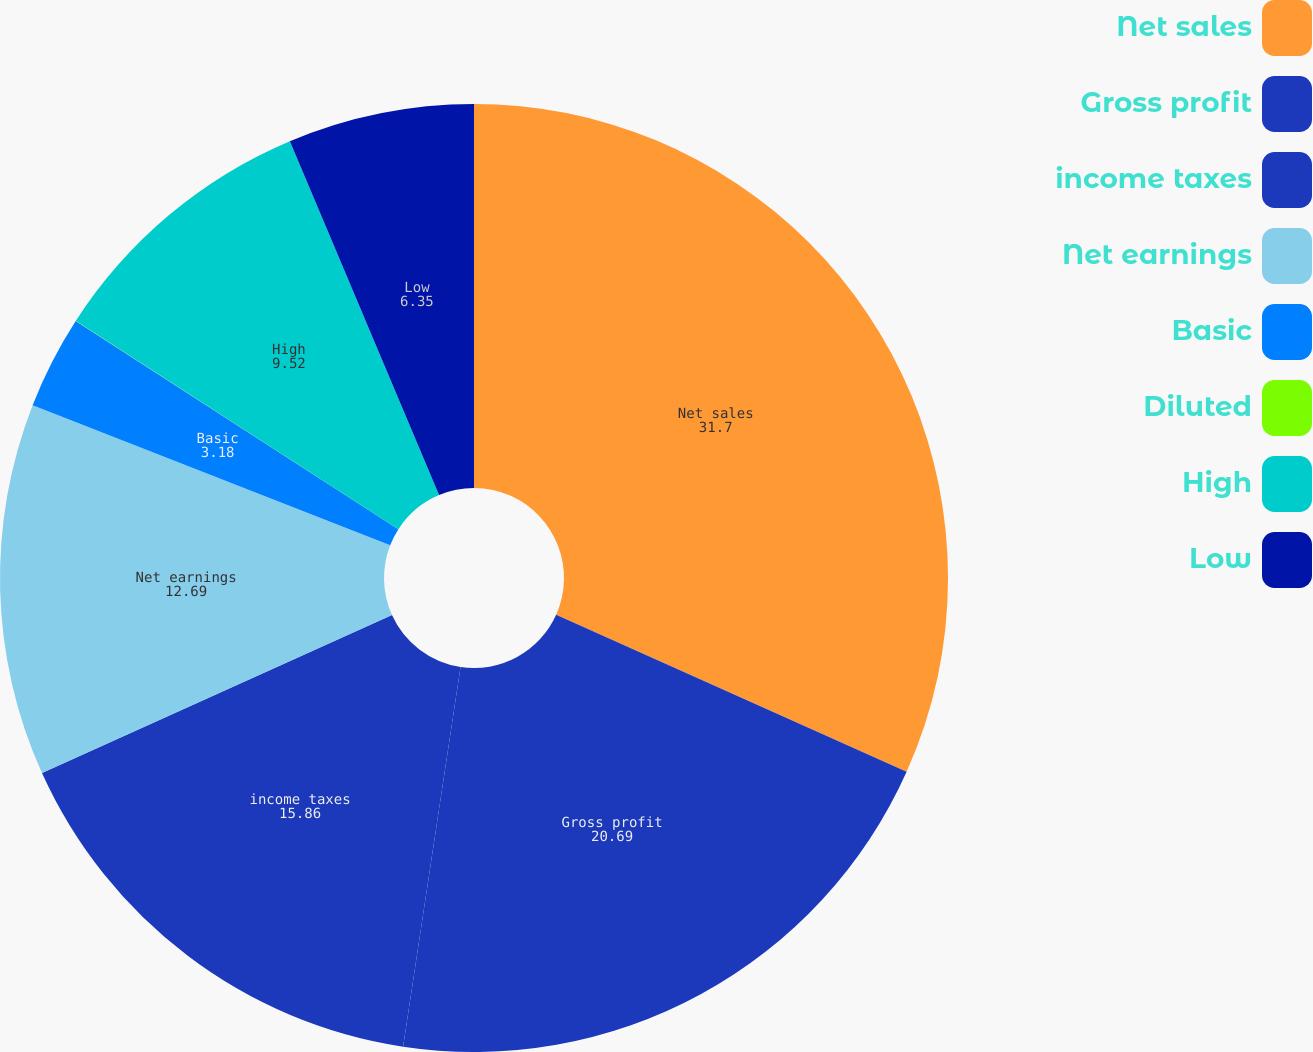<chart> <loc_0><loc_0><loc_500><loc_500><pie_chart><fcel>Net sales<fcel>Gross profit<fcel>income taxes<fcel>Net earnings<fcel>Basic<fcel>Diluted<fcel>High<fcel>Low<nl><fcel>31.7%<fcel>20.69%<fcel>15.86%<fcel>12.69%<fcel>3.18%<fcel>0.01%<fcel>9.52%<fcel>6.35%<nl></chart> 